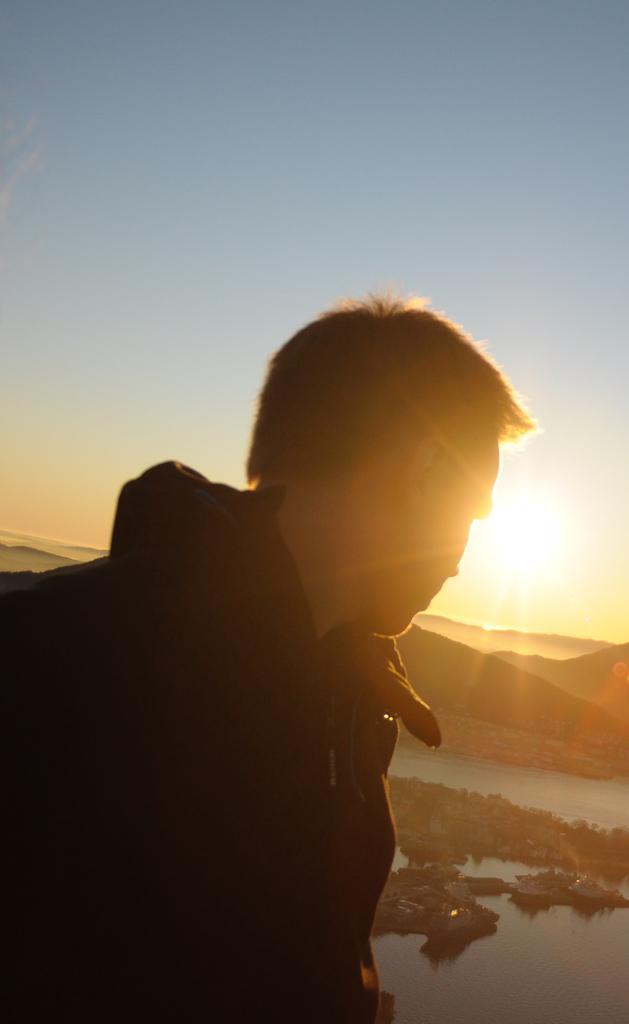Please provide a concise description of this image. In this image at the top we can see the sky and sun. In the background there are few hills. There is a pond with water. There are many rocks. On the left side of the image there is a man. 